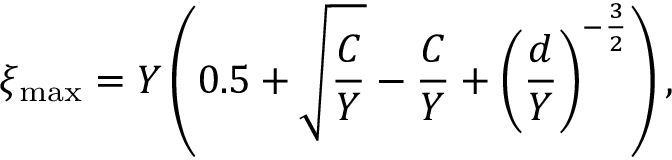<formula> <loc_0><loc_0><loc_500><loc_500>\xi _ { \max } = Y \left ( 0 . 5 + \sqrt { } C } { Y } - \frac { C } { Y } + \left ( \frac { d } { Y } \right ) ^ { - \frac { 3 } { 2 } } \right ) ,</formula> 